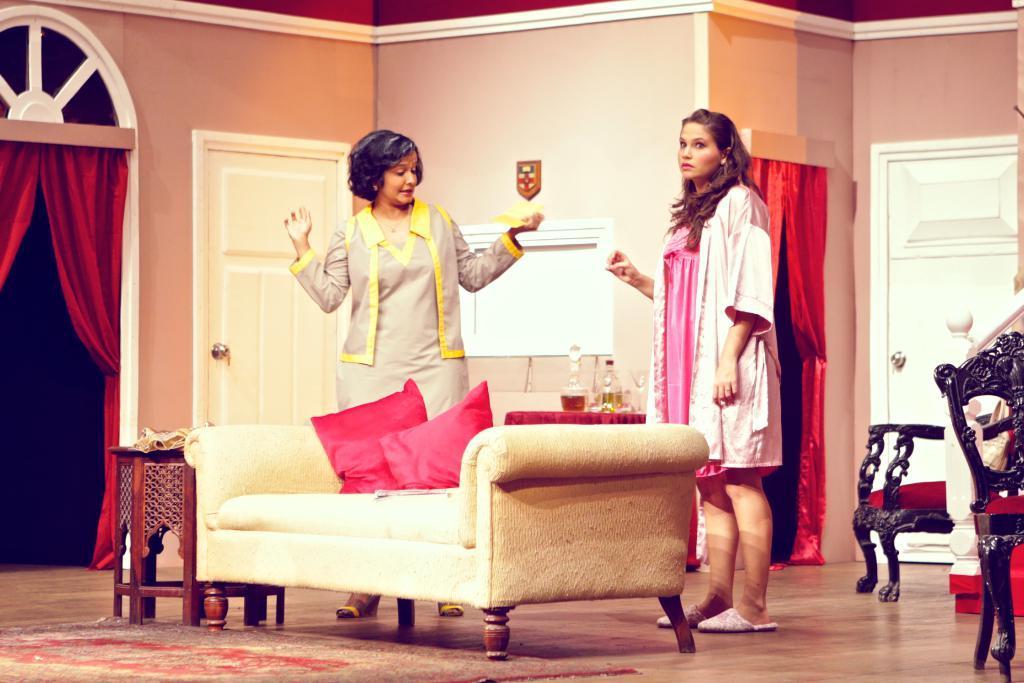In one or two sentences, can you explain what this image depicts? In this image I can see two women are standing. I can also see a sofa and few cushions on it. In the background I can see chairs, curtains and a door. 